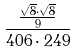<formula> <loc_0><loc_0><loc_500><loc_500>\frac { \frac { \sqrt { 8 } \cdot \sqrt { 8 } } { 9 } } { 4 0 6 \cdot 2 4 9 }</formula> 